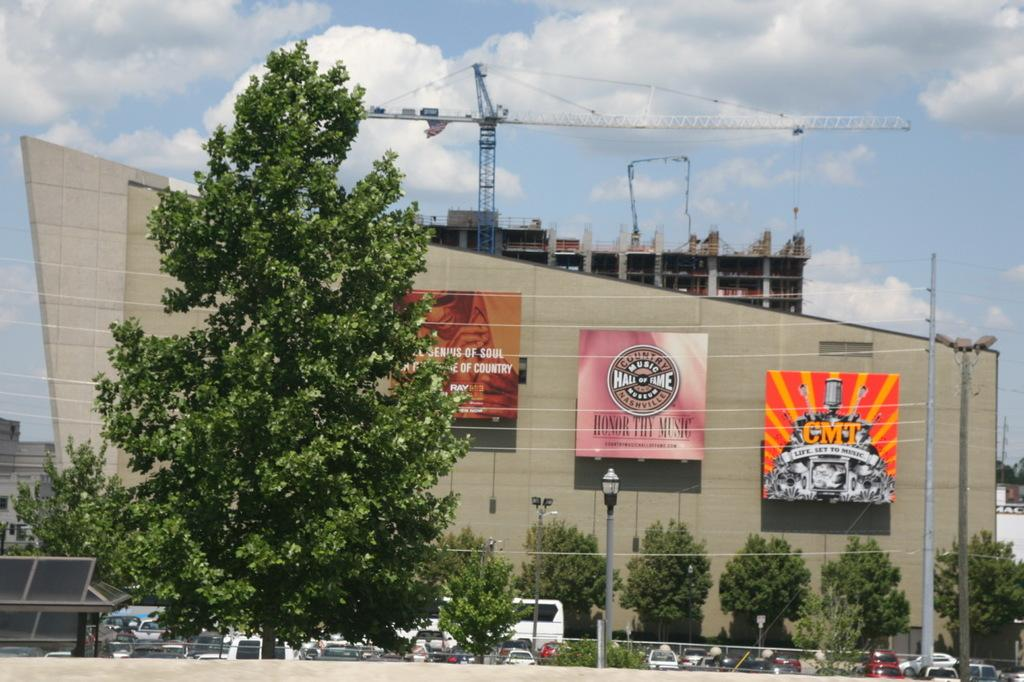What can be seen in the middle of the image? There are trees, posters, buildings, a tower, poles, street lights, cars, and vehicles in the middle of the image. What is visible at the top of the image? The sky is visible at the top of the image. What can be observed in the sky? Clouds are present in the sky. What advice does the dad give to the person in the image? There is no dad present in the image, so it is not possible to answer that question. What is the sum of the number of trees and posters in the image? The image does not require us to perform any addition, as the facts provided are about the presence of objects, not their quantities. 